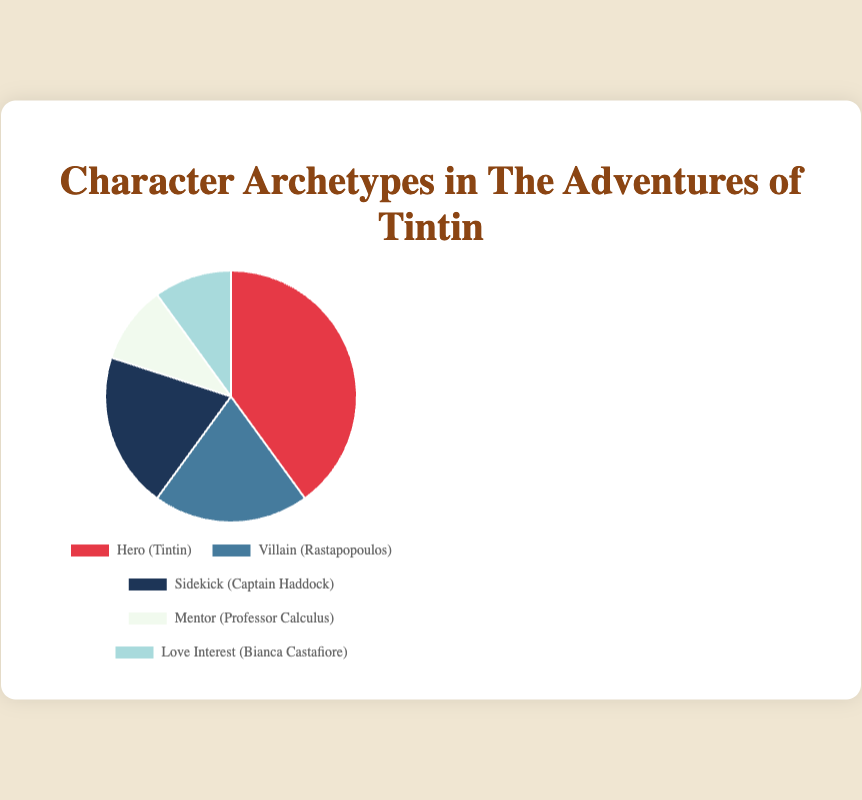What is the largest character archetype in The Adventures of Tintin? To identify the largest character archetype, look at the percentages of each slice in the pie chart. The largest percentage is 40%, which corresponds to the 'Hero' archetype represented by Tintin.
Answer: Hero Which two archetypes are equally represented in the series? Find archetypes with the same percentage value in the pie chart. Both the 'Mentor' and 'Love Interest' archetypes are represented by 10% each.
Answer: Mentor and Love Interest How much larger is the representation of the Hero archetype compared to the Villain archetype? Subtract the percentage of the Villain archetype from that of the Hero archetype: 40% - 20% = 20%.
Answer: 20% What is the combined percentage of supporting roles (Sidekick, Mentor, and Love Interest) in the series? Add the percentages for Sidekick, Mentor, and Love Interest: 20% + 10% + 10% = 40%.
Answer: 40% Which archetype has the smallest representation and what is its percentage? Identify the archetype with the smallest slice in the pie chart. Both 'Mentor' and 'Love Interest' have the smallest percentages at 10%.
Answer: Mentor and Love Interest, 10% How does the combined percentage of Villain and Sidekick archetypes compare to the Hero archetype? Add the percentages for Villain and Sidekick: 20% + 20% = 40%, then compare it to the percentage of the Hero archetype: 40%. Both are equal.
Answer: Equal, 40% What color represents Captain Haddock's character in the pie chart? Look at the segment labeled 'Sidekick (Captain Haddock)' and describe its color. Captain Haddock's segment is visually colored blue in the pie chart.
Answer: Blue 